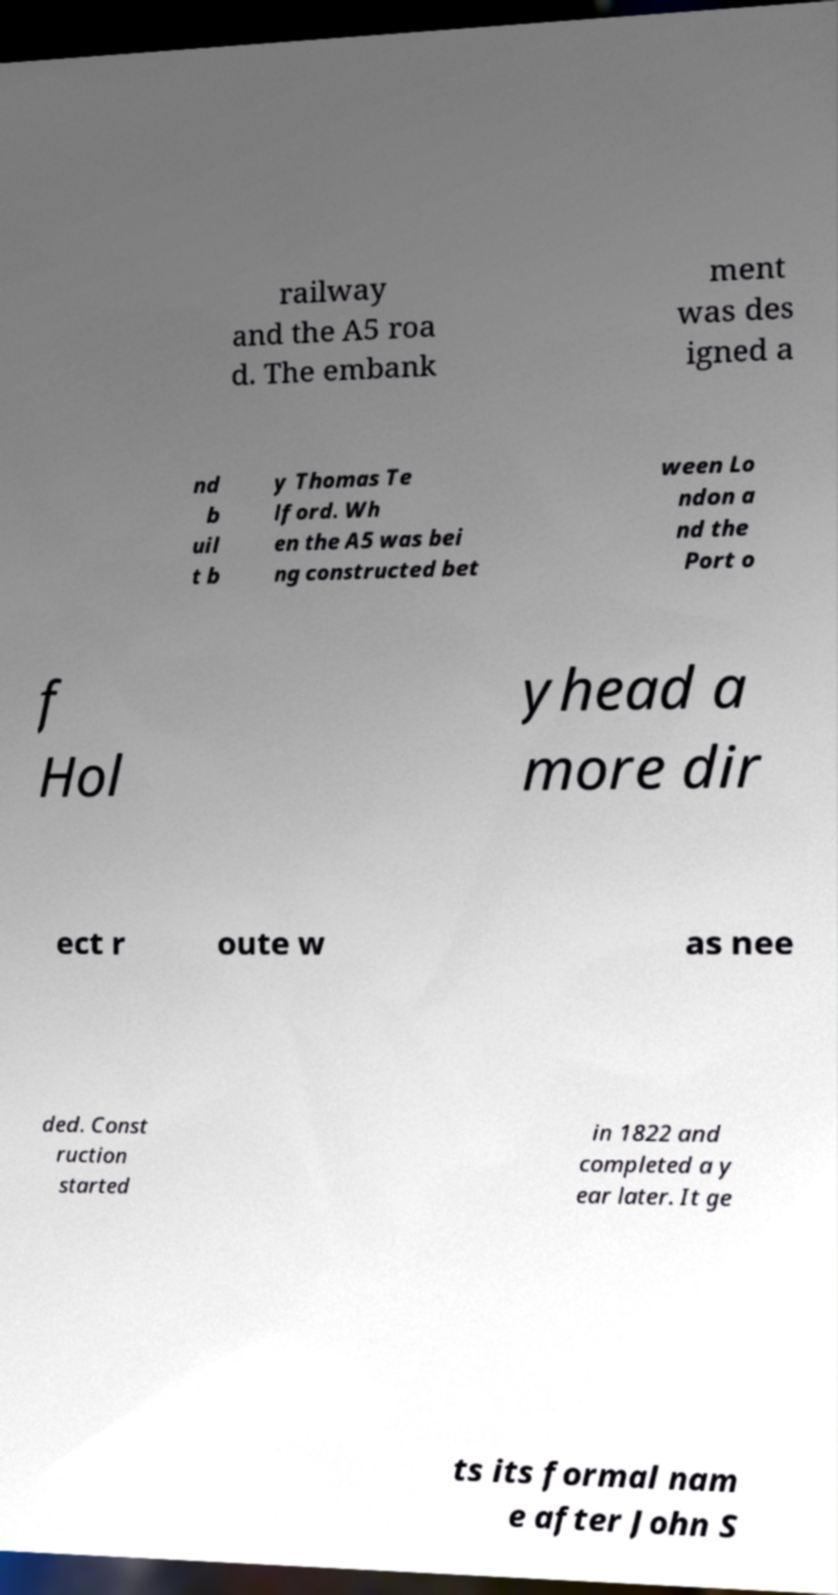Please identify and transcribe the text found in this image. railway and the A5 roa d. The embank ment was des igned a nd b uil t b y Thomas Te lford. Wh en the A5 was bei ng constructed bet ween Lo ndon a nd the Port o f Hol yhead a more dir ect r oute w as nee ded. Const ruction started in 1822 and completed a y ear later. It ge ts its formal nam e after John S 